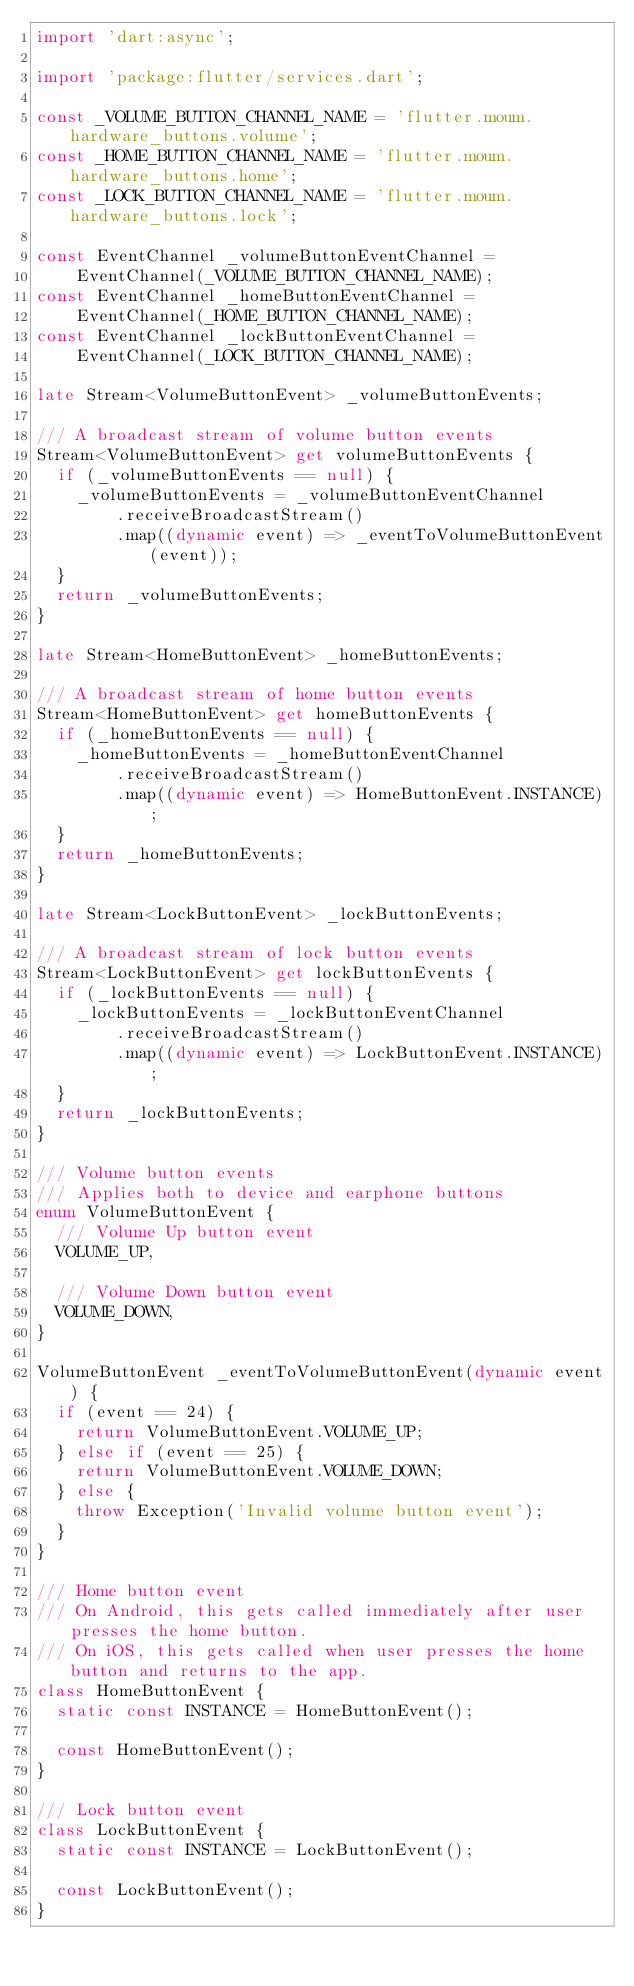<code> <loc_0><loc_0><loc_500><loc_500><_Dart_>import 'dart:async';

import 'package:flutter/services.dart';

const _VOLUME_BUTTON_CHANNEL_NAME = 'flutter.moum.hardware_buttons.volume';
const _HOME_BUTTON_CHANNEL_NAME = 'flutter.moum.hardware_buttons.home';
const _LOCK_BUTTON_CHANNEL_NAME = 'flutter.moum.hardware_buttons.lock';

const EventChannel _volumeButtonEventChannel =
    EventChannel(_VOLUME_BUTTON_CHANNEL_NAME);
const EventChannel _homeButtonEventChannel =
    EventChannel(_HOME_BUTTON_CHANNEL_NAME);
const EventChannel _lockButtonEventChannel =
    EventChannel(_LOCK_BUTTON_CHANNEL_NAME);

late Stream<VolumeButtonEvent> _volumeButtonEvents;

/// A broadcast stream of volume button events
Stream<VolumeButtonEvent> get volumeButtonEvents {
  if (_volumeButtonEvents == null) {
    _volumeButtonEvents = _volumeButtonEventChannel
        .receiveBroadcastStream()
        .map((dynamic event) => _eventToVolumeButtonEvent(event));
  }
  return _volumeButtonEvents;
}

late Stream<HomeButtonEvent> _homeButtonEvents;

/// A broadcast stream of home button events
Stream<HomeButtonEvent> get homeButtonEvents {
  if (_homeButtonEvents == null) {
    _homeButtonEvents = _homeButtonEventChannel
        .receiveBroadcastStream()
        .map((dynamic event) => HomeButtonEvent.INSTANCE);
  }
  return _homeButtonEvents;
}

late Stream<LockButtonEvent> _lockButtonEvents;

/// A broadcast stream of lock button events
Stream<LockButtonEvent> get lockButtonEvents {
  if (_lockButtonEvents == null) {
    _lockButtonEvents = _lockButtonEventChannel
        .receiveBroadcastStream()
        .map((dynamic event) => LockButtonEvent.INSTANCE);
  }
  return _lockButtonEvents;
}

/// Volume button events
/// Applies both to device and earphone buttons
enum VolumeButtonEvent {
  /// Volume Up button event
  VOLUME_UP,

  /// Volume Down button event
  VOLUME_DOWN,
}

VolumeButtonEvent _eventToVolumeButtonEvent(dynamic event) {
  if (event == 24) {
    return VolumeButtonEvent.VOLUME_UP;
  } else if (event == 25) {
    return VolumeButtonEvent.VOLUME_DOWN;
  } else {
    throw Exception('Invalid volume button event');
  }
}

/// Home button event
/// On Android, this gets called immediately after user presses the home button.
/// On iOS, this gets called when user presses the home button and returns to the app.
class HomeButtonEvent {
  static const INSTANCE = HomeButtonEvent();

  const HomeButtonEvent();
}

/// Lock button event
class LockButtonEvent {
  static const INSTANCE = LockButtonEvent();

  const LockButtonEvent();
}
</code> 